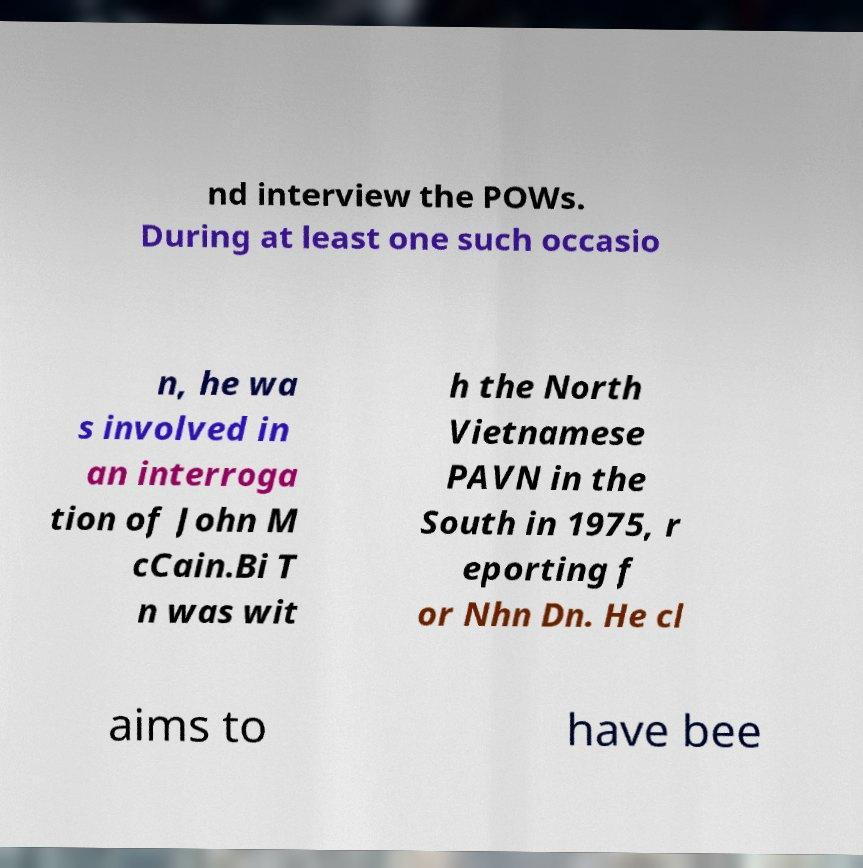Could you extract and type out the text from this image? nd interview the POWs. During at least one such occasio n, he wa s involved in an interroga tion of John M cCain.Bi T n was wit h the North Vietnamese PAVN in the South in 1975, r eporting f or Nhn Dn. He cl aims to have bee 